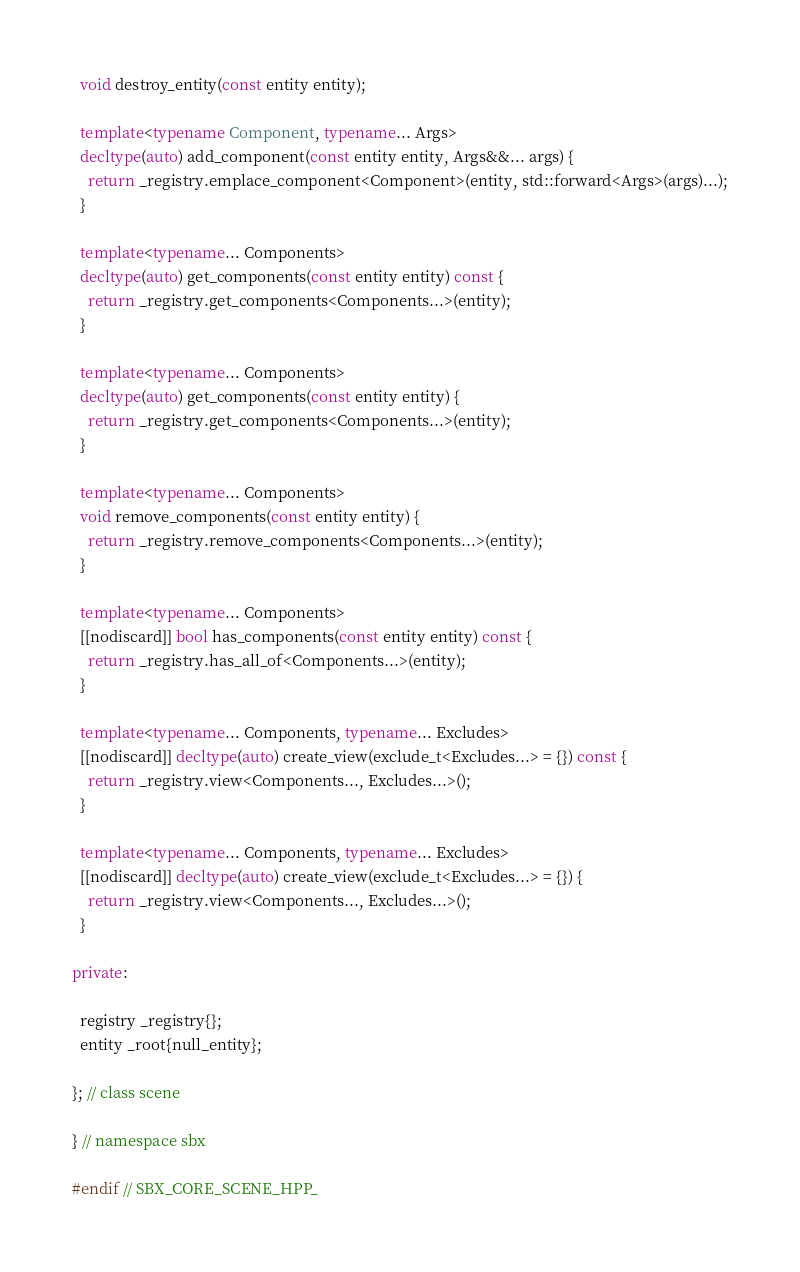Convert code to text. <code><loc_0><loc_0><loc_500><loc_500><_C++_>
  void destroy_entity(const entity entity);

  template<typename Component, typename... Args>
  decltype(auto) add_component(const entity entity, Args&&... args) {
    return _registry.emplace_component<Component>(entity, std::forward<Args>(args)...);
  }

  template<typename... Components>
  decltype(auto) get_components(const entity entity) const {
    return _registry.get_components<Components...>(entity);
  }

  template<typename... Components>
  decltype(auto) get_components(const entity entity) {
    return _registry.get_components<Components...>(entity);
  }

  template<typename... Components>
  void remove_components(const entity entity) {
    return _registry.remove_components<Components...>(entity);
  }

  template<typename... Components>
  [[nodiscard]] bool has_components(const entity entity) const {
    return _registry.has_all_of<Components...>(entity);
  }

  template<typename... Components, typename... Excludes>
  [[nodiscard]] decltype(auto) create_view(exclude_t<Excludes...> = {}) const {
    return _registry.view<Components..., Excludes...>();
  }

  template<typename... Components, typename... Excludes>
  [[nodiscard]] decltype(auto) create_view(exclude_t<Excludes...> = {}) {
    return _registry.view<Components..., Excludes...>();
  }

private:

  registry _registry{};
  entity _root{null_entity};

}; // class scene

} // namespace sbx

#endif // SBX_CORE_SCENE_HPP_
</code> 